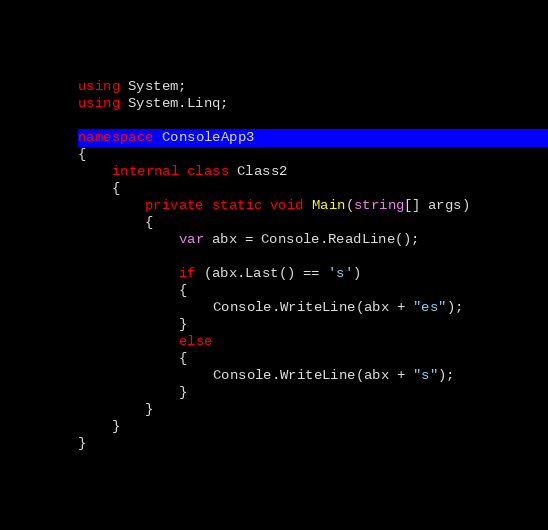<code> <loc_0><loc_0><loc_500><loc_500><_C#_>using System;
using System.Linq;

namespace ConsoleApp3
{
    internal class Class2
    {
        private static void Main(string[] args)
        {
            var abx = Console.ReadLine();

            if (abx.Last() == 's')
            {
                Console.WriteLine(abx + "es");
            }
            else
            {
                Console.WriteLine(abx + "s");
            }
        }
    }
}</code> 